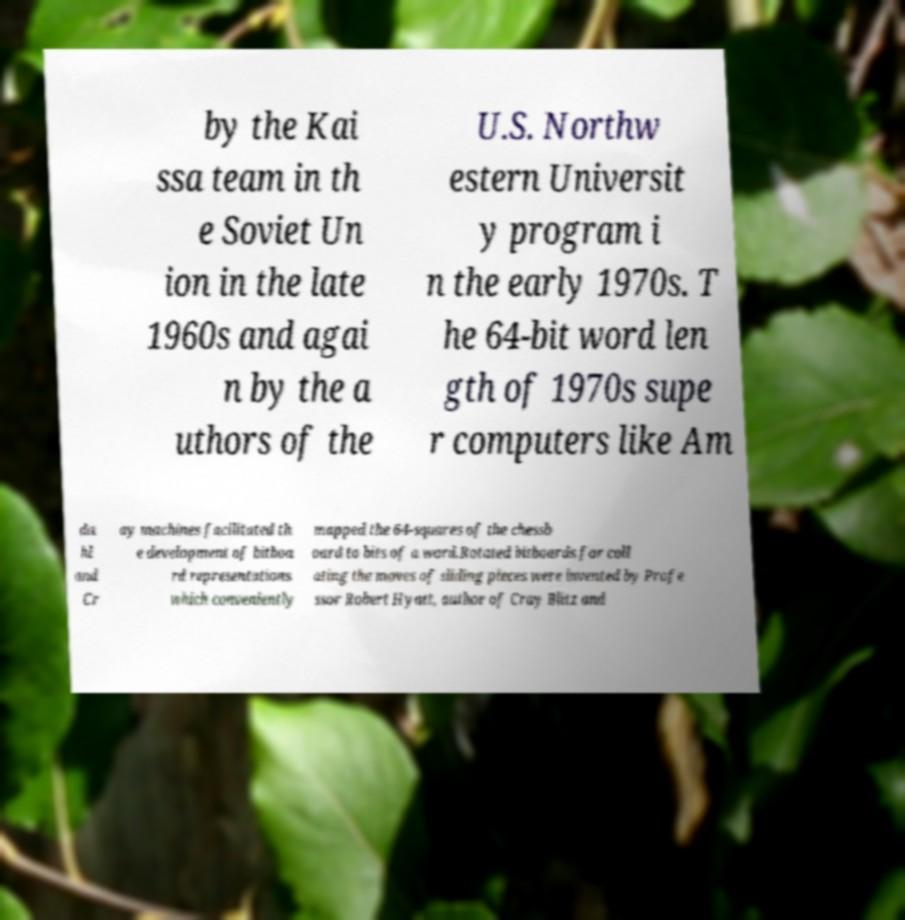I need the written content from this picture converted into text. Can you do that? by the Kai ssa team in th e Soviet Un ion in the late 1960s and agai n by the a uthors of the U.S. Northw estern Universit y program i n the early 1970s. T he 64-bit word len gth of 1970s supe r computers like Am da hl and Cr ay machines facilitated th e development of bitboa rd representations which conveniently mapped the 64-squares of the chessb oard to bits of a word.Rotated bitboards for coll ating the moves of sliding pieces were invented by Profe ssor Robert Hyatt, author of Cray Blitz and 